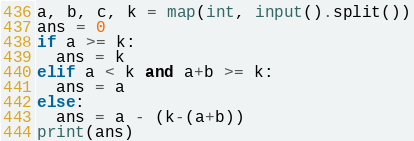<code> <loc_0><loc_0><loc_500><loc_500><_Python_>a, b, c, k = map(int, input().split())
ans = 0
if a >= k:
  ans = k
elif a < k and a+b >= k:
  ans = a
else:
  ans = a - (k-(a+b))
print(ans)</code> 